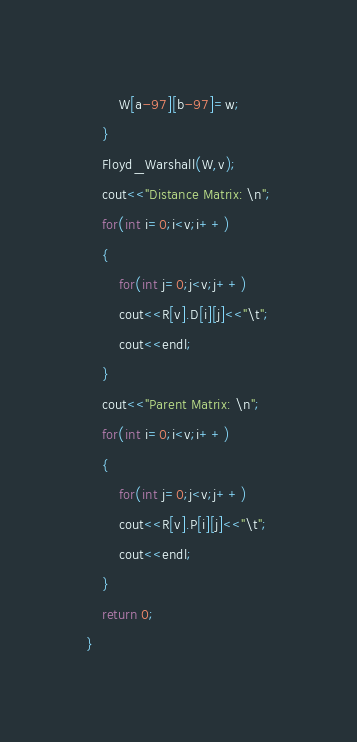Convert code to text. <code><loc_0><loc_0><loc_500><loc_500><_C++_>		W[a-97][b-97]=w;
	}
	Floyd_Warshall(W,v);
	cout<<"Distance Matrix: \n";
	for(int i=0;i<v;i++)
	{
		for(int j=0;j<v;j++)
		cout<<R[v].D[i][j]<<"\t";
		cout<<endl;
	}
	cout<<"Parent Matrix: \n";
	for(int i=0;i<v;i++)
	{
		for(int j=0;j<v;j++)
		cout<<R[v].P[i][j]<<"\t";
		cout<<endl;
	}
	return 0;
}
</code> 